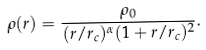Convert formula to latex. <formula><loc_0><loc_0><loc_500><loc_500>\rho ( r ) = \frac { \rho _ { 0 } } { ( r / r _ { c } ) ^ { \alpha } ( 1 + r / r _ { c } ) ^ { 2 } } .</formula> 